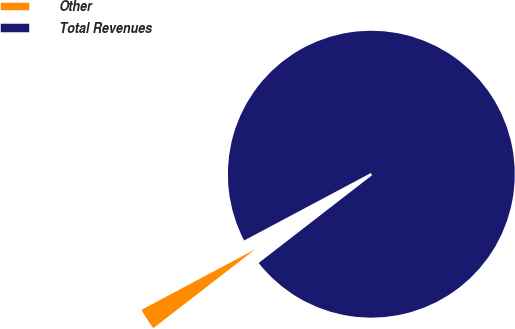<chart> <loc_0><loc_0><loc_500><loc_500><pie_chart><fcel>Other<fcel>Total Revenues<nl><fcel>2.7%<fcel>97.3%<nl></chart> 